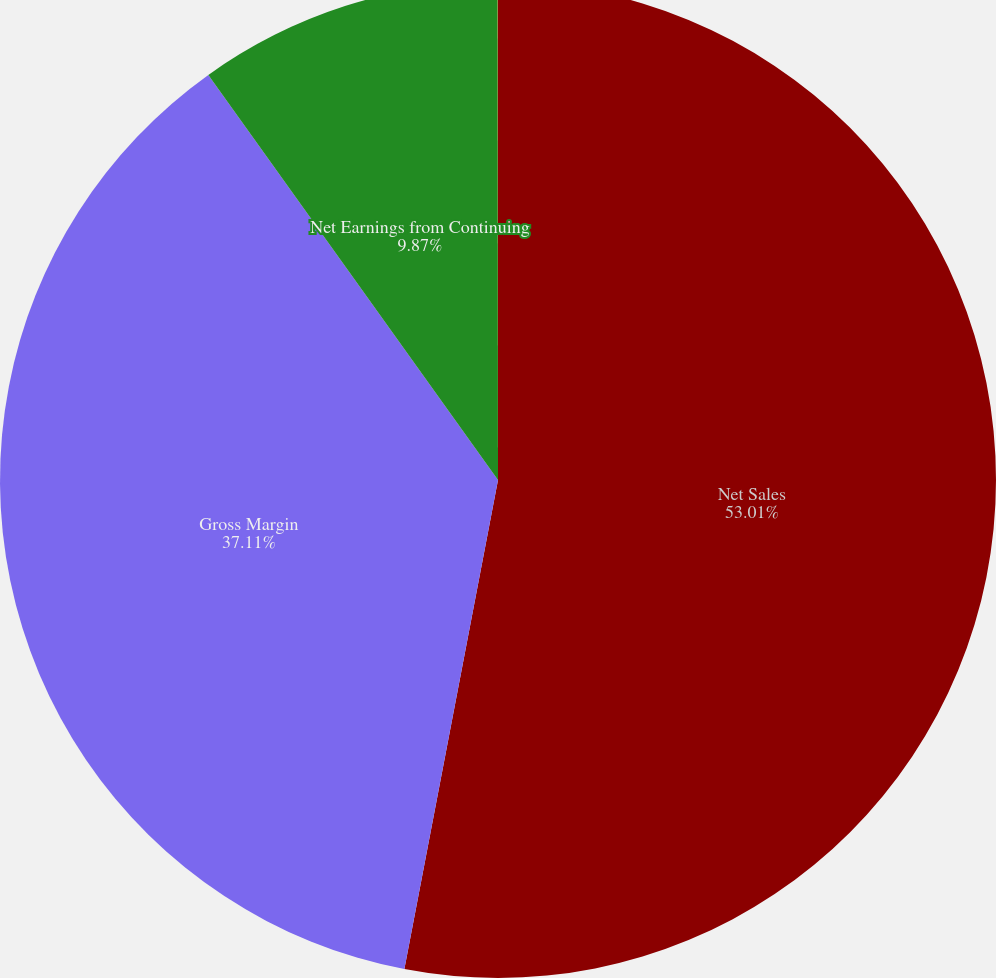<chart> <loc_0><loc_0><loc_500><loc_500><pie_chart><fcel>Net Sales<fcel>Gross Margin<fcel>Net Earnings from Continuing<fcel>Net Earnings from Discontinued<nl><fcel>53.01%<fcel>37.11%<fcel>9.87%<fcel>0.01%<nl></chart> 